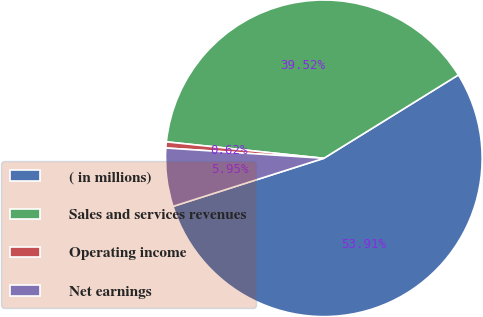<chart> <loc_0><loc_0><loc_500><loc_500><pie_chart><fcel>( in millions)<fcel>Sales and services revenues<fcel>Operating income<fcel>Net earnings<nl><fcel>53.92%<fcel>39.52%<fcel>0.62%<fcel>5.95%<nl></chart> 